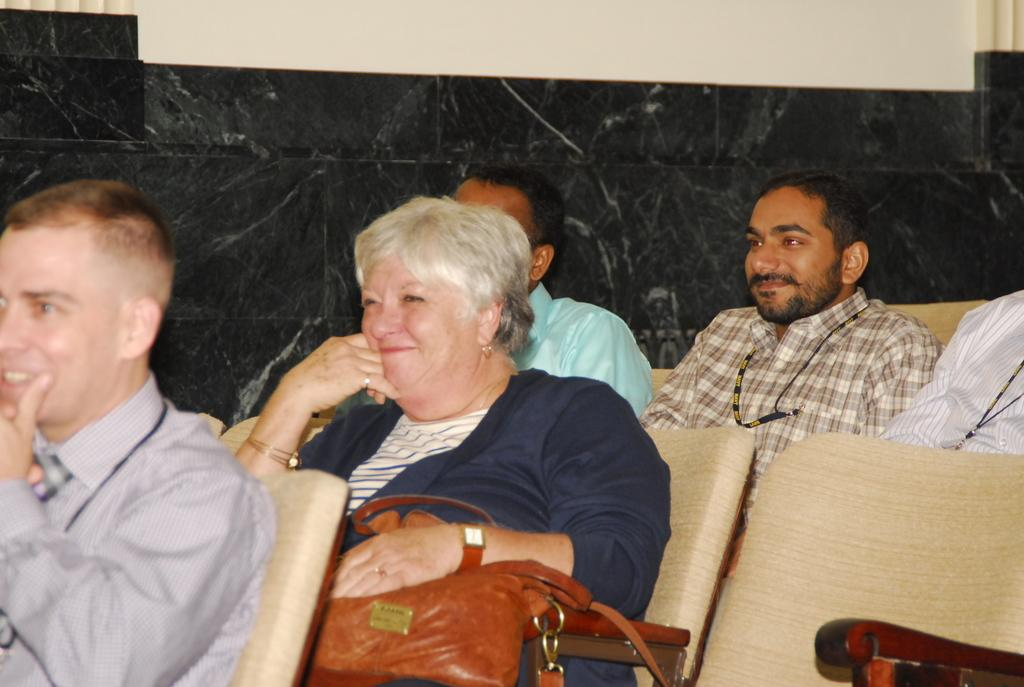How many people are in the image? There are people in the image, but the exact number is not specified. What are the people doing in the image? The people are sitting and smiling in the image. What type of furniture is present in the image? Chairs are present in the image. What object can be seen near the people? There is a bag in the image. What is visible in the background of the image? There is a wall in the background of the image. What type of hole can be seen in the shirt of the person in the image? There is no shirt or hole present in the image; the people are sitting and smiling, and no clothing details are mentioned. 